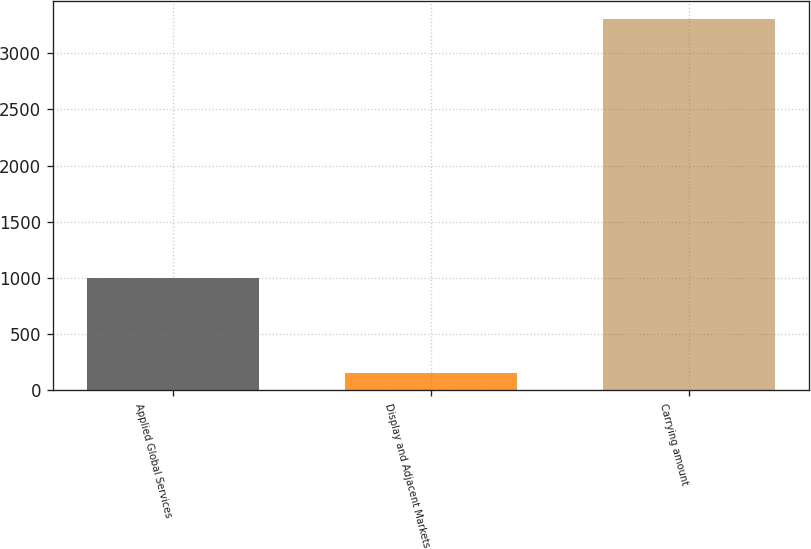<chart> <loc_0><loc_0><loc_500><loc_500><bar_chart><fcel>Applied Global Services<fcel>Display and Adjacent Markets<fcel>Carrying amount<nl><fcel>996<fcel>155<fcel>3302<nl></chart> 